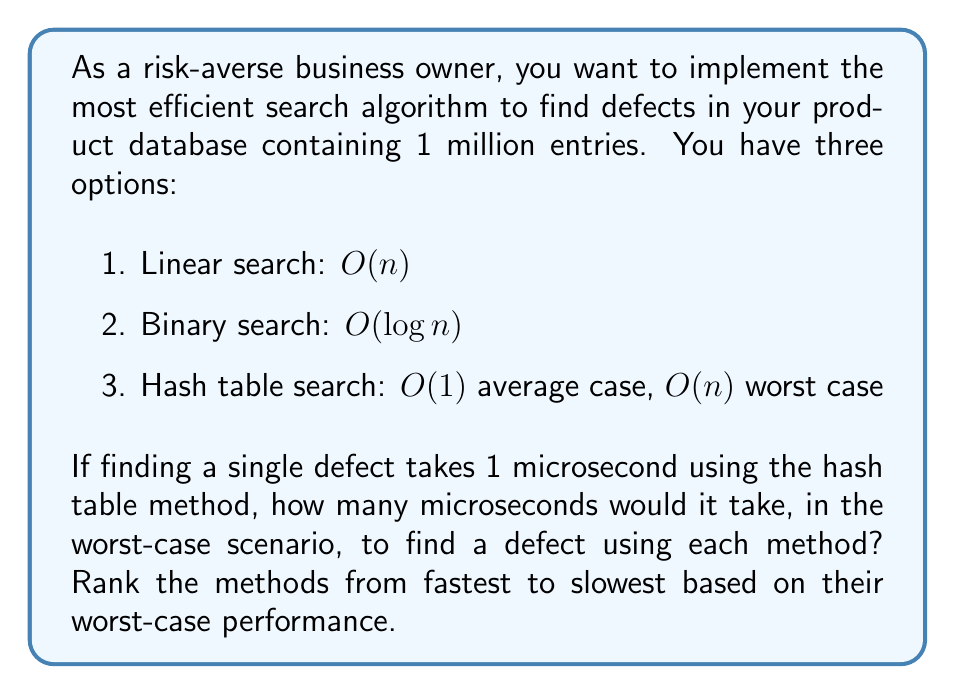What is the answer to this math problem? To solve this problem, we need to calculate the worst-case time for each search method:

1. Linear search: $O(n)$
   Worst case: $1,000,000 \times 1\mu s = 1,000,000\mu s$

2. Binary search: $O(\log n)$
   Worst case: $\log_2(1,000,000) \times 1\mu s \approx 19.93\mu s \approx 20\mu s$

3. Hash table search: $O(1)$ average case, $O(n)$ worst case
   Worst case: $1,000,000 \times 1\mu s = 1,000,000\mu s$

Now, let's rank the methods from fastest to slowest based on their worst-case performance:

1. Binary search: $20\mu s$
2. Linear search: $1,000,000\mu s$
3. Hash table search: $1,000,000\mu s$

Note that while the hash table search has the same worst-case performance as linear search, it typically performs much better in average cases. However, as a risk-averse business owner focused on worst-case scenarios, we rank it last due to its potential for poor performance in certain situations.
Answer: Worst-case times:
Linear search: $1,000,000\mu s$
Binary search: $20\mu s$
Hash table search: $1,000,000\mu s$

Ranking from fastest to slowest (worst-case):
1. Binary search
2. Linear search
3. Hash table search 